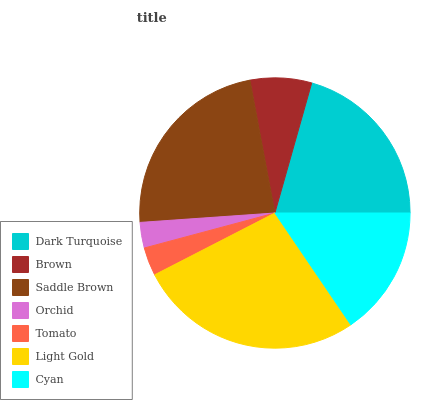Is Orchid the minimum?
Answer yes or no. Yes. Is Light Gold the maximum?
Answer yes or no. Yes. Is Brown the minimum?
Answer yes or no. No. Is Brown the maximum?
Answer yes or no. No. Is Dark Turquoise greater than Brown?
Answer yes or no. Yes. Is Brown less than Dark Turquoise?
Answer yes or no. Yes. Is Brown greater than Dark Turquoise?
Answer yes or no. No. Is Dark Turquoise less than Brown?
Answer yes or no. No. Is Cyan the high median?
Answer yes or no. Yes. Is Cyan the low median?
Answer yes or no. Yes. Is Tomato the high median?
Answer yes or no. No. Is Tomato the low median?
Answer yes or no. No. 